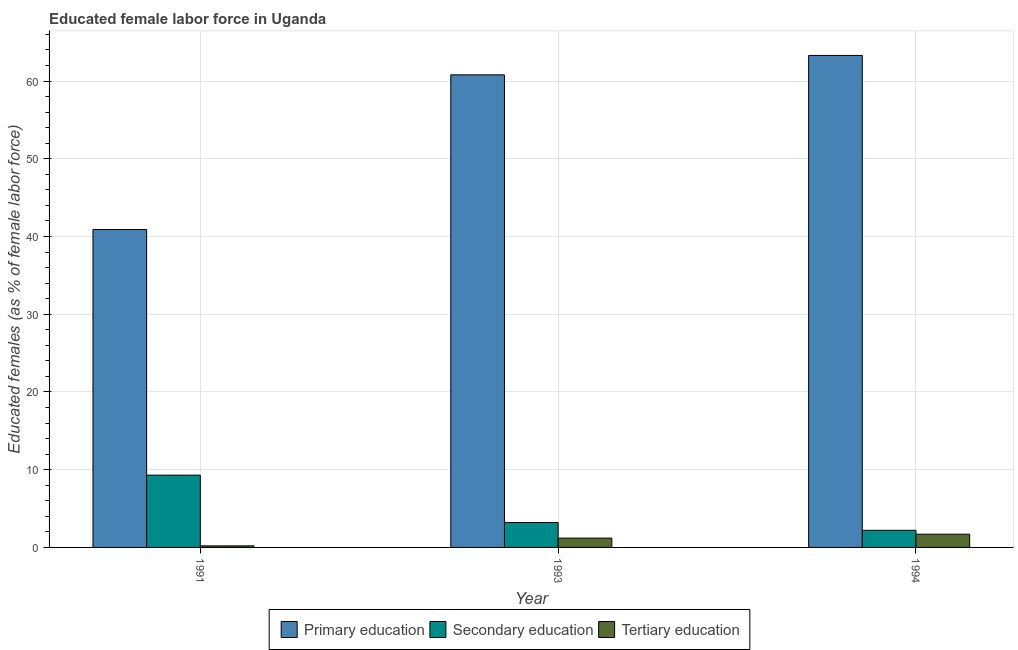How many different coloured bars are there?
Ensure brevity in your answer.  3. How many groups of bars are there?
Your answer should be compact. 3. Are the number of bars per tick equal to the number of legend labels?
Keep it short and to the point. Yes. Are the number of bars on each tick of the X-axis equal?
Provide a succinct answer. Yes. How many bars are there on the 1st tick from the right?
Ensure brevity in your answer.  3. What is the label of the 2nd group of bars from the left?
Make the answer very short. 1993. In how many cases, is the number of bars for a given year not equal to the number of legend labels?
Your response must be concise. 0. What is the percentage of female labor force who received primary education in 1991?
Ensure brevity in your answer.  40.9. Across all years, what is the maximum percentage of female labor force who received secondary education?
Offer a very short reply. 9.3. Across all years, what is the minimum percentage of female labor force who received secondary education?
Provide a succinct answer. 2.2. What is the total percentage of female labor force who received primary education in the graph?
Offer a terse response. 165. What is the difference between the percentage of female labor force who received primary education in 1991 and that in 1993?
Your answer should be compact. -19.9. What is the difference between the percentage of female labor force who received tertiary education in 1993 and the percentage of female labor force who received primary education in 1991?
Ensure brevity in your answer.  1. What is the average percentage of female labor force who received secondary education per year?
Your answer should be very brief. 4.9. In how many years, is the percentage of female labor force who received tertiary education greater than 6 %?
Ensure brevity in your answer.  0. What is the ratio of the percentage of female labor force who received tertiary education in 1993 to that in 1994?
Ensure brevity in your answer.  0.71. Is the percentage of female labor force who received secondary education in 1993 less than that in 1994?
Provide a short and direct response. No. Is the difference between the percentage of female labor force who received primary education in 1991 and 1994 greater than the difference between the percentage of female labor force who received secondary education in 1991 and 1994?
Make the answer very short. No. What is the difference between the highest and the lowest percentage of female labor force who received secondary education?
Your answer should be very brief. 7.1. In how many years, is the percentage of female labor force who received secondary education greater than the average percentage of female labor force who received secondary education taken over all years?
Your answer should be compact. 1. Is the sum of the percentage of female labor force who received primary education in 1991 and 1993 greater than the maximum percentage of female labor force who received tertiary education across all years?
Offer a terse response. Yes. What does the 1st bar from the left in 1991 represents?
Provide a succinct answer. Primary education. What does the 1st bar from the right in 1991 represents?
Offer a terse response. Tertiary education. Are all the bars in the graph horizontal?
Give a very brief answer. No. How many years are there in the graph?
Your answer should be very brief. 3. Does the graph contain any zero values?
Offer a terse response. No. Where does the legend appear in the graph?
Keep it short and to the point. Bottom center. How many legend labels are there?
Offer a terse response. 3. What is the title of the graph?
Provide a succinct answer. Educated female labor force in Uganda. Does "Services" appear as one of the legend labels in the graph?
Keep it short and to the point. No. What is the label or title of the X-axis?
Make the answer very short. Year. What is the label or title of the Y-axis?
Your answer should be compact. Educated females (as % of female labor force). What is the Educated females (as % of female labor force) of Primary education in 1991?
Your answer should be very brief. 40.9. What is the Educated females (as % of female labor force) in Secondary education in 1991?
Your response must be concise. 9.3. What is the Educated females (as % of female labor force) of Tertiary education in 1991?
Offer a terse response. 0.2. What is the Educated females (as % of female labor force) in Primary education in 1993?
Offer a terse response. 60.8. What is the Educated females (as % of female labor force) of Secondary education in 1993?
Your response must be concise. 3.2. What is the Educated females (as % of female labor force) of Tertiary education in 1993?
Your response must be concise. 1.2. What is the Educated females (as % of female labor force) of Primary education in 1994?
Ensure brevity in your answer.  63.3. What is the Educated females (as % of female labor force) in Secondary education in 1994?
Offer a very short reply. 2.2. What is the Educated females (as % of female labor force) in Tertiary education in 1994?
Your answer should be compact. 1.7. Across all years, what is the maximum Educated females (as % of female labor force) in Primary education?
Ensure brevity in your answer.  63.3. Across all years, what is the maximum Educated females (as % of female labor force) in Secondary education?
Ensure brevity in your answer.  9.3. Across all years, what is the maximum Educated females (as % of female labor force) in Tertiary education?
Provide a short and direct response. 1.7. Across all years, what is the minimum Educated females (as % of female labor force) in Primary education?
Keep it short and to the point. 40.9. Across all years, what is the minimum Educated females (as % of female labor force) of Secondary education?
Give a very brief answer. 2.2. Across all years, what is the minimum Educated females (as % of female labor force) of Tertiary education?
Your response must be concise. 0.2. What is the total Educated females (as % of female labor force) of Primary education in the graph?
Provide a short and direct response. 165. What is the total Educated females (as % of female labor force) in Secondary education in the graph?
Keep it short and to the point. 14.7. What is the total Educated females (as % of female labor force) of Tertiary education in the graph?
Your answer should be very brief. 3.1. What is the difference between the Educated females (as % of female labor force) in Primary education in 1991 and that in 1993?
Your answer should be very brief. -19.9. What is the difference between the Educated females (as % of female labor force) in Secondary education in 1991 and that in 1993?
Give a very brief answer. 6.1. What is the difference between the Educated females (as % of female labor force) in Primary education in 1991 and that in 1994?
Your response must be concise. -22.4. What is the difference between the Educated females (as % of female labor force) in Secondary education in 1991 and that in 1994?
Ensure brevity in your answer.  7.1. What is the difference between the Educated females (as % of female labor force) of Primary education in 1993 and that in 1994?
Your response must be concise. -2.5. What is the difference between the Educated females (as % of female labor force) of Primary education in 1991 and the Educated females (as % of female labor force) of Secondary education in 1993?
Your response must be concise. 37.7. What is the difference between the Educated females (as % of female labor force) in Primary education in 1991 and the Educated females (as % of female labor force) in Tertiary education in 1993?
Offer a terse response. 39.7. What is the difference between the Educated females (as % of female labor force) of Secondary education in 1991 and the Educated females (as % of female labor force) of Tertiary education in 1993?
Offer a very short reply. 8.1. What is the difference between the Educated females (as % of female labor force) in Primary education in 1991 and the Educated females (as % of female labor force) in Secondary education in 1994?
Offer a very short reply. 38.7. What is the difference between the Educated females (as % of female labor force) of Primary education in 1991 and the Educated females (as % of female labor force) of Tertiary education in 1994?
Give a very brief answer. 39.2. What is the difference between the Educated females (as % of female labor force) in Secondary education in 1991 and the Educated females (as % of female labor force) in Tertiary education in 1994?
Provide a succinct answer. 7.6. What is the difference between the Educated females (as % of female labor force) in Primary education in 1993 and the Educated females (as % of female labor force) in Secondary education in 1994?
Make the answer very short. 58.6. What is the difference between the Educated females (as % of female labor force) of Primary education in 1993 and the Educated females (as % of female labor force) of Tertiary education in 1994?
Provide a short and direct response. 59.1. What is the difference between the Educated females (as % of female labor force) of Secondary education in 1993 and the Educated females (as % of female labor force) of Tertiary education in 1994?
Keep it short and to the point. 1.5. In the year 1991, what is the difference between the Educated females (as % of female labor force) in Primary education and Educated females (as % of female labor force) in Secondary education?
Your response must be concise. 31.6. In the year 1991, what is the difference between the Educated females (as % of female labor force) of Primary education and Educated females (as % of female labor force) of Tertiary education?
Your answer should be very brief. 40.7. In the year 1991, what is the difference between the Educated females (as % of female labor force) in Secondary education and Educated females (as % of female labor force) in Tertiary education?
Make the answer very short. 9.1. In the year 1993, what is the difference between the Educated females (as % of female labor force) of Primary education and Educated females (as % of female labor force) of Secondary education?
Your answer should be compact. 57.6. In the year 1993, what is the difference between the Educated females (as % of female labor force) of Primary education and Educated females (as % of female labor force) of Tertiary education?
Your answer should be compact. 59.6. In the year 1994, what is the difference between the Educated females (as % of female labor force) of Primary education and Educated females (as % of female labor force) of Secondary education?
Provide a short and direct response. 61.1. In the year 1994, what is the difference between the Educated females (as % of female labor force) of Primary education and Educated females (as % of female labor force) of Tertiary education?
Your answer should be compact. 61.6. What is the ratio of the Educated females (as % of female labor force) in Primary education in 1991 to that in 1993?
Your answer should be compact. 0.67. What is the ratio of the Educated females (as % of female labor force) of Secondary education in 1991 to that in 1993?
Provide a short and direct response. 2.91. What is the ratio of the Educated females (as % of female labor force) of Tertiary education in 1991 to that in 1993?
Your answer should be compact. 0.17. What is the ratio of the Educated females (as % of female labor force) of Primary education in 1991 to that in 1994?
Your response must be concise. 0.65. What is the ratio of the Educated females (as % of female labor force) in Secondary education in 1991 to that in 1994?
Your response must be concise. 4.23. What is the ratio of the Educated females (as % of female labor force) in Tertiary education in 1991 to that in 1994?
Offer a very short reply. 0.12. What is the ratio of the Educated females (as % of female labor force) in Primary education in 1993 to that in 1994?
Provide a succinct answer. 0.96. What is the ratio of the Educated females (as % of female labor force) of Secondary education in 1993 to that in 1994?
Offer a very short reply. 1.45. What is the ratio of the Educated females (as % of female labor force) of Tertiary education in 1993 to that in 1994?
Offer a terse response. 0.71. What is the difference between the highest and the lowest Educated females (as % of female labor force) in Primary education?
Give a very brief answer. 22.4. What is the difference between the highest and the lowest Educated females (as % of female labor force) of Secondary education?
Ensure brevity in your answer.  7.1. What is the difference between the highest and the lowest Educated females (as % of female labor force) in Tertiary education?
Provide a short and direct response. 1.5. 